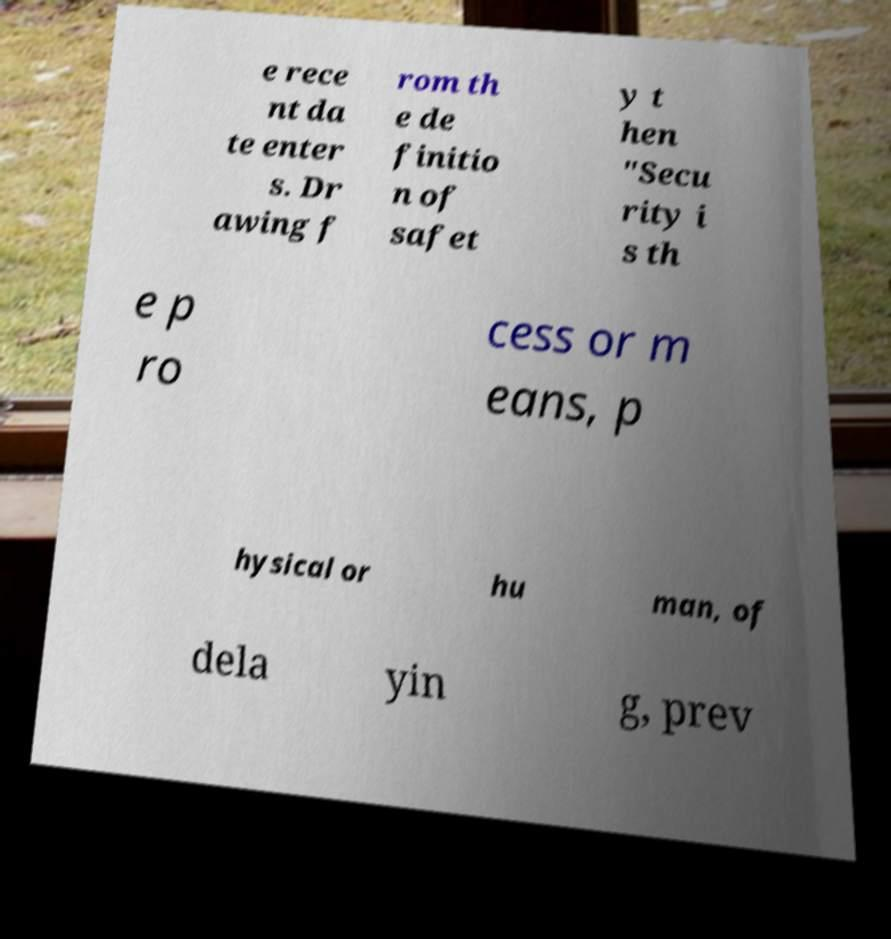Can you accurately transcribe the text from the provided image for me? e rece nt da te enter s. Dr awing f rom th e de finitio n of safet y t hen "Secu rity i s th e p ro cess or m eans, p hysical or hu man, of dela yin g, prev 